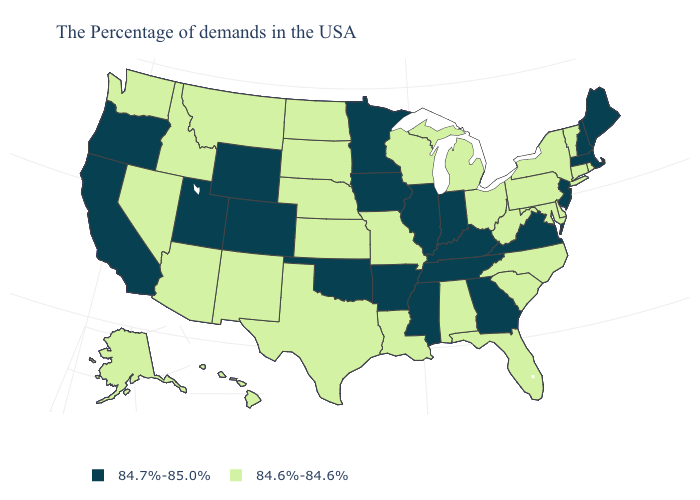Does Georgia have the highest value in the South?
Write a very short answer. Yes. Name the states that have a value in the range 84.7%-85.0%?
Concise answer only. Maine, Massachusetts, New Hampshire, New Jersey, Virginia, Georgia, Kentucky, Indiana, Tennessee, Illinois, Mississippi, Arkansas, Minnesota, Iowa, Oklahoma, Wyoming, Colorado, Utah, California, Oregon. Name the states that have a value in the range 84.7%-85.0%?
Give a very brief answer. Maine, Massachusetts, New Hampshire, New Jersey, Virginia, Georgia, Kentucky, Indiana, Tennessee, Illinois, Mississippi, Arkansas, Minnesota, Iowa, Oklahoma, Wyoming, Colorado, Utah, California, Oregon. Name the states that have a value in the range 84.7%-85.0%?
Give a very brief answer. Maine, Massachusetts, New Hampshire, New Jersey, Virginia, Georgia, Kentucky, Indiana, Tennessee, Illinois, Mississippi, Arkansas, Minnesota, Iowa, Oklahoma, Wyoming, Colorado, Utah, California, Oregon. What is the value of Kansas?
Concise answer only. 84.6%-84.6%. What is the lowest value in states that border Wisconsin?
Keep it brief. 84.6%-84.6%. Does the first symbol in the legend represent the smallest category?
Give a very brief answer. No. Does the first symbol in the legend represent the smallest category?
Answer briefly. No. What is the lowest value in states that border New Hampshire?
Be succinct. 84.6%-84.6%. What is the lowest value in the South?
Quick response, please. 84.6%-84.6%. Does Georgia have the lowest value in the USA?
Give a very brief answer. No. Does Indiana have the lowest value in the MidWest?
Write a very short answer. No. What is the value of Wyoming?
Write a very short answer. 84.7%-85.0%. Among the states that border Maine , which have the lowest value?
Keep it brief. New Hampshire. 